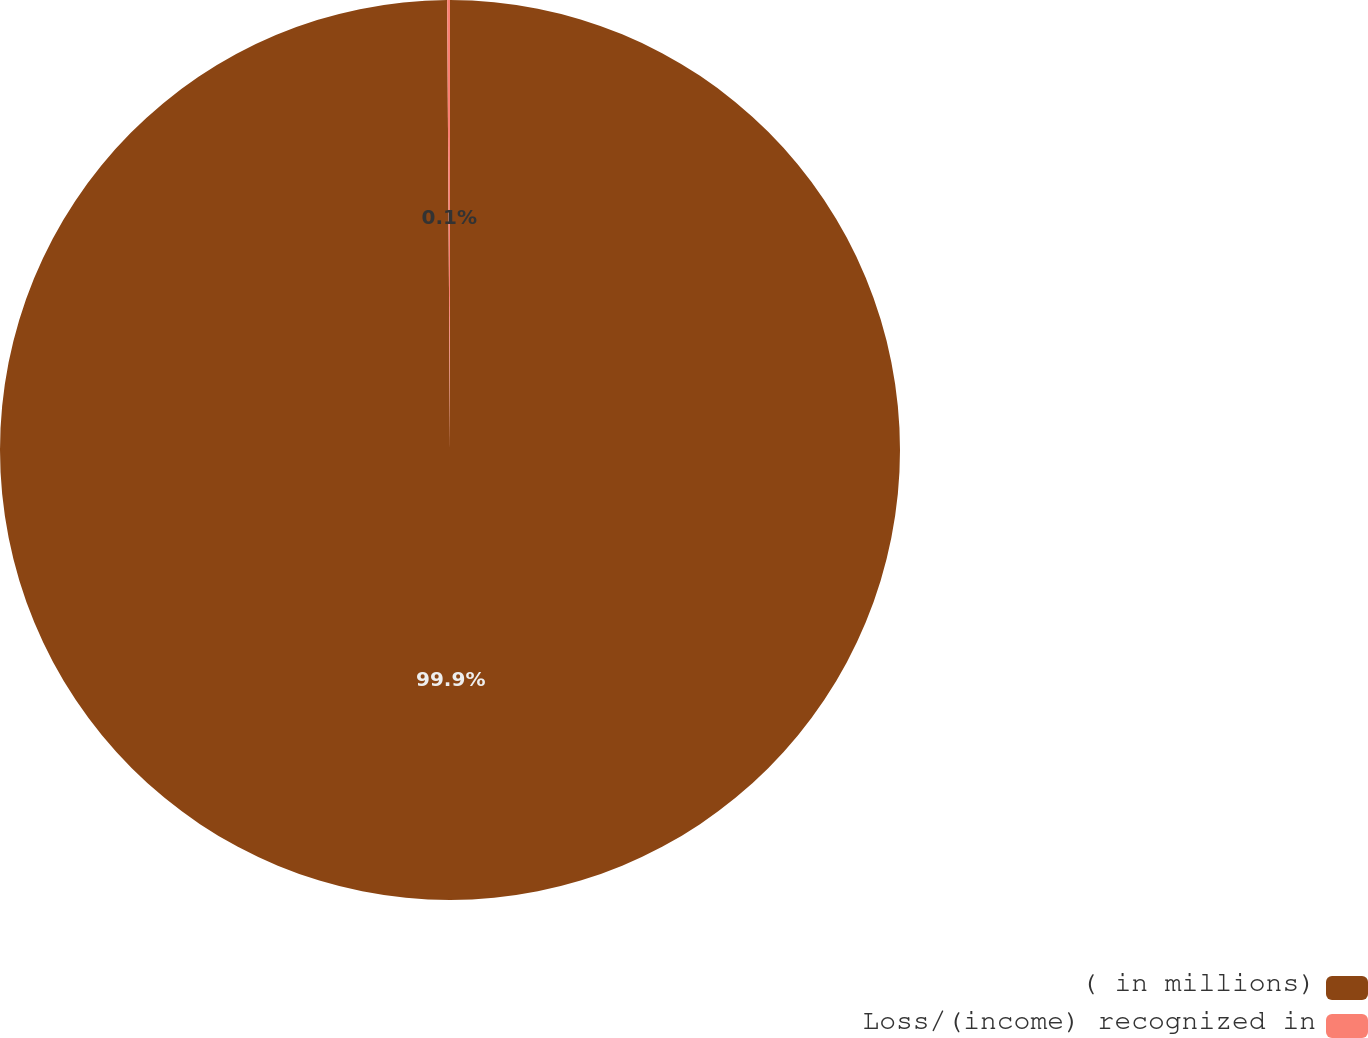Convert chart. <chart><loc_0><loc_0><loc_500><loc_500><pie_chart><fcel>( in millions)<fcel>Loss/(income) recognized in<nl><fcel>99.9%<fcel>0.1%<nl></chart> 